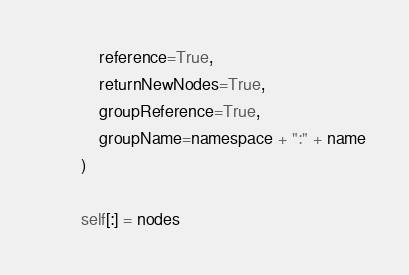<code> <loc_0><loc_0><loc_500><loc_500><_Python_>            reference=True,
            returnNewNodes=True,
            groupReference=True,
            groupName=namespace + ":" + name
        )

        self[:] = nodes
</code> 